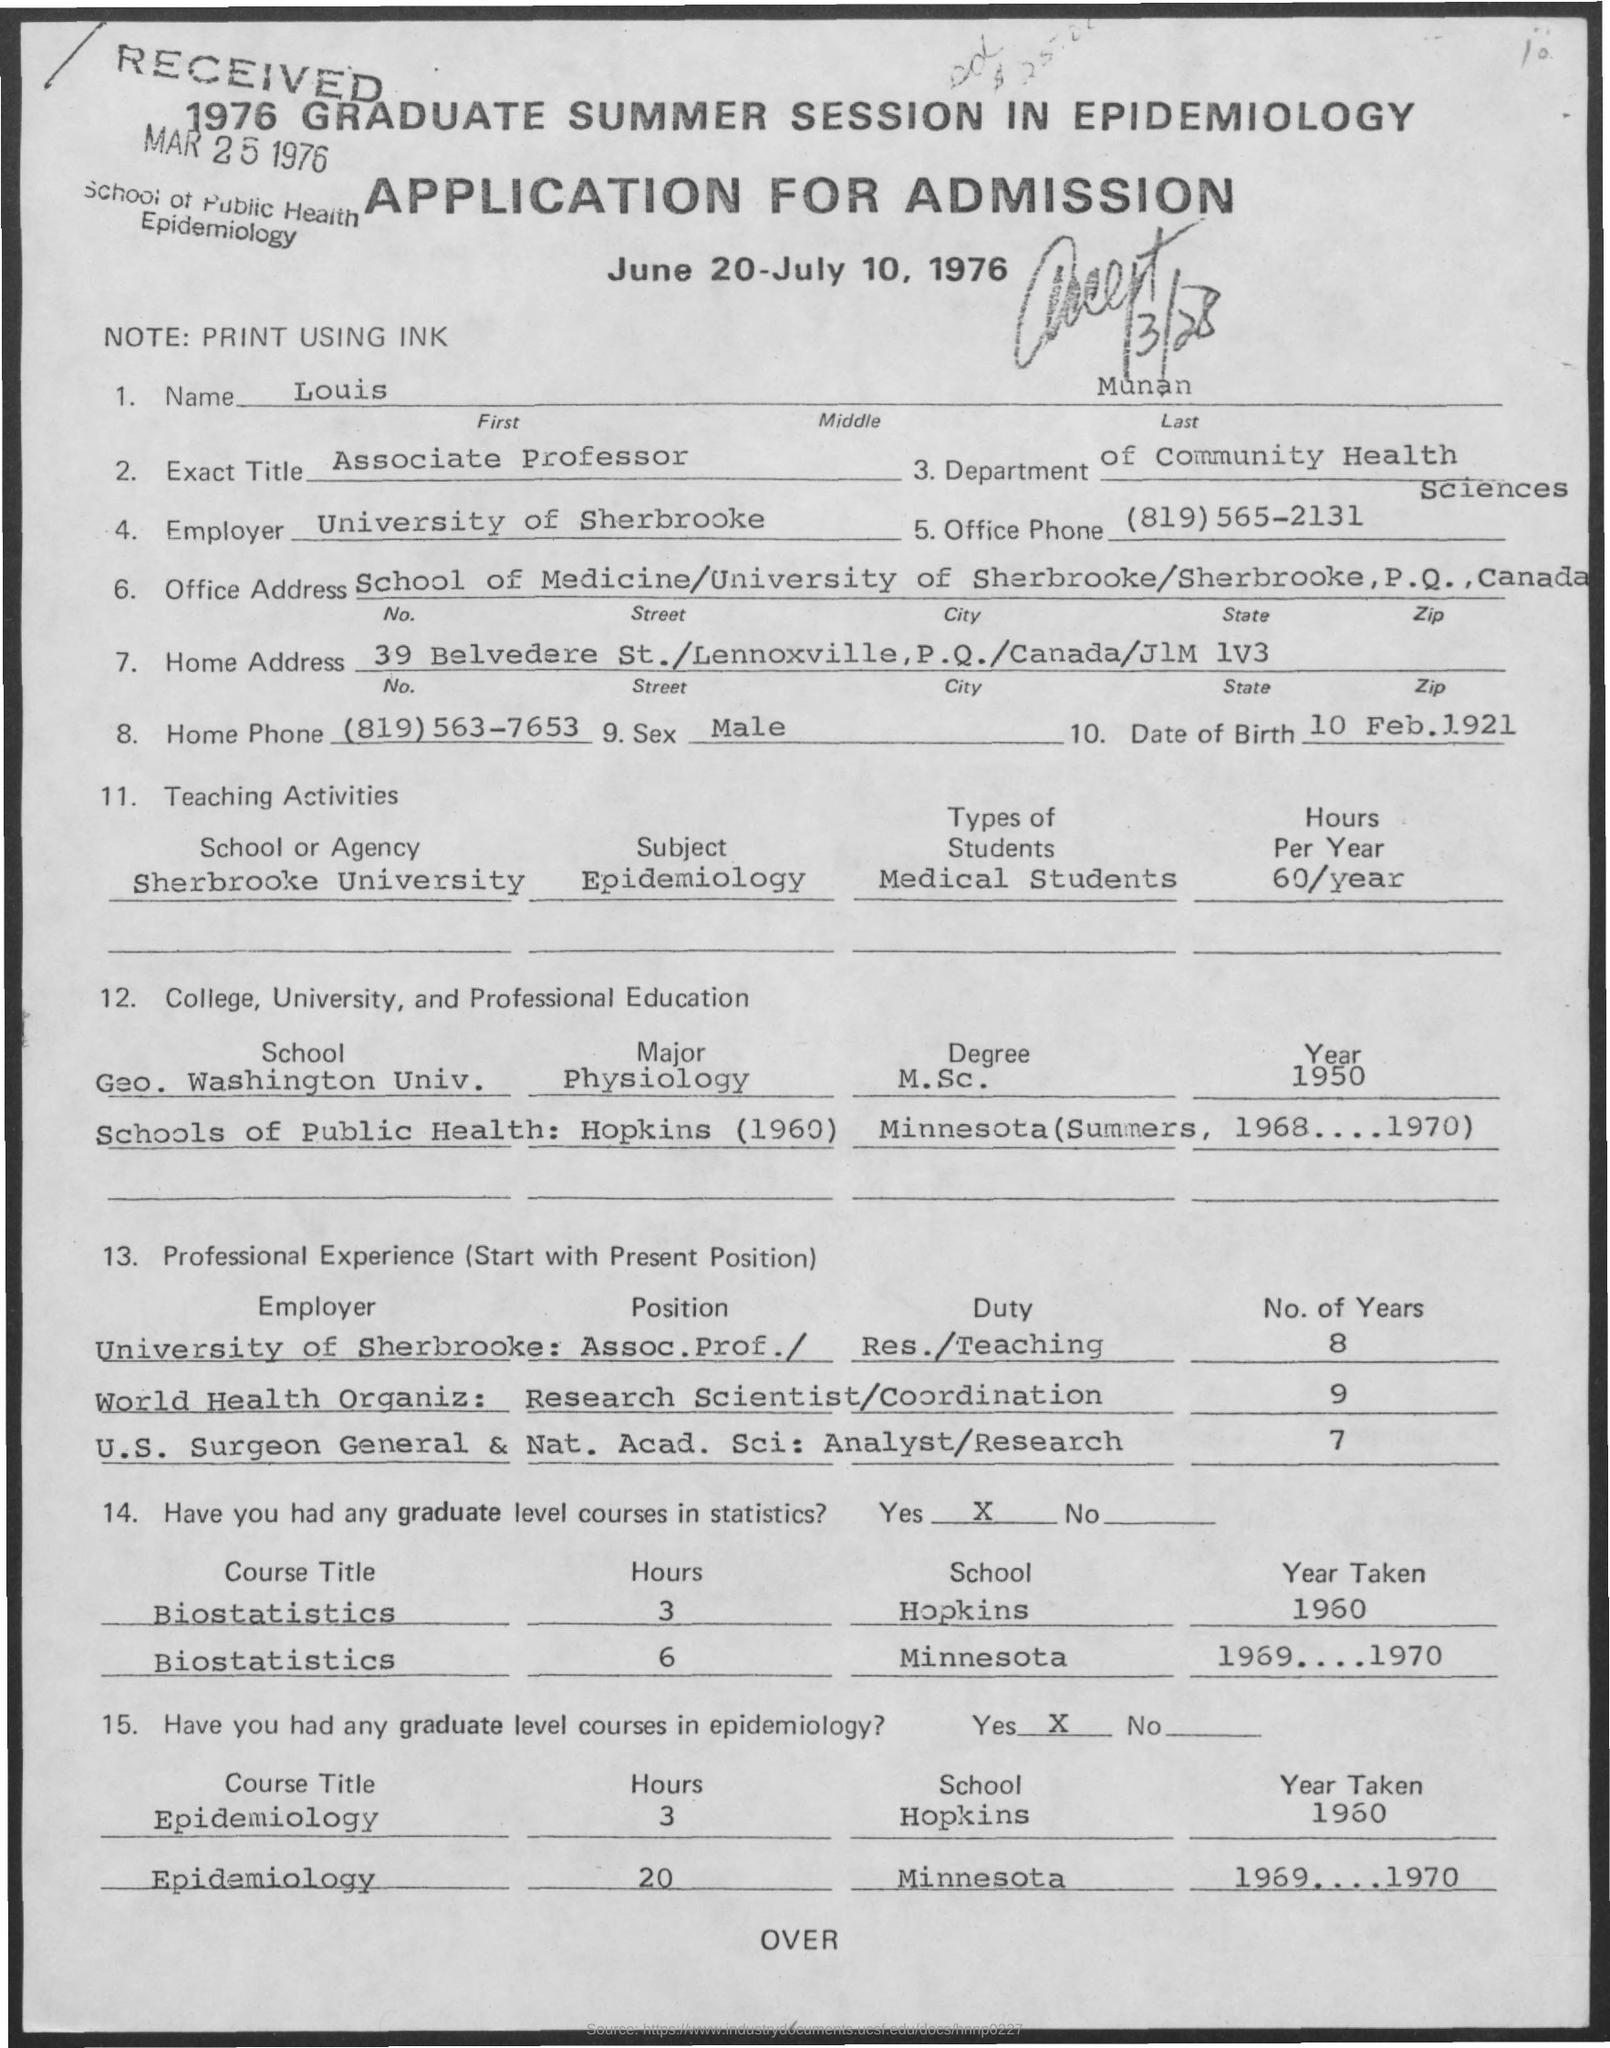Identify some key points in this picture. Louis Munan completed his M.Sc. degree in Physiology from the George Washington University in 1950. Louis Munan was assigned the duty of coordination as a Research Scientist in the World Health Organization. Louis Munan is currently employed by the University of Sherbrooke. Louis Munan is an Associate Professor. Louis Munan is employed in the Department of Community Health Sciences. 